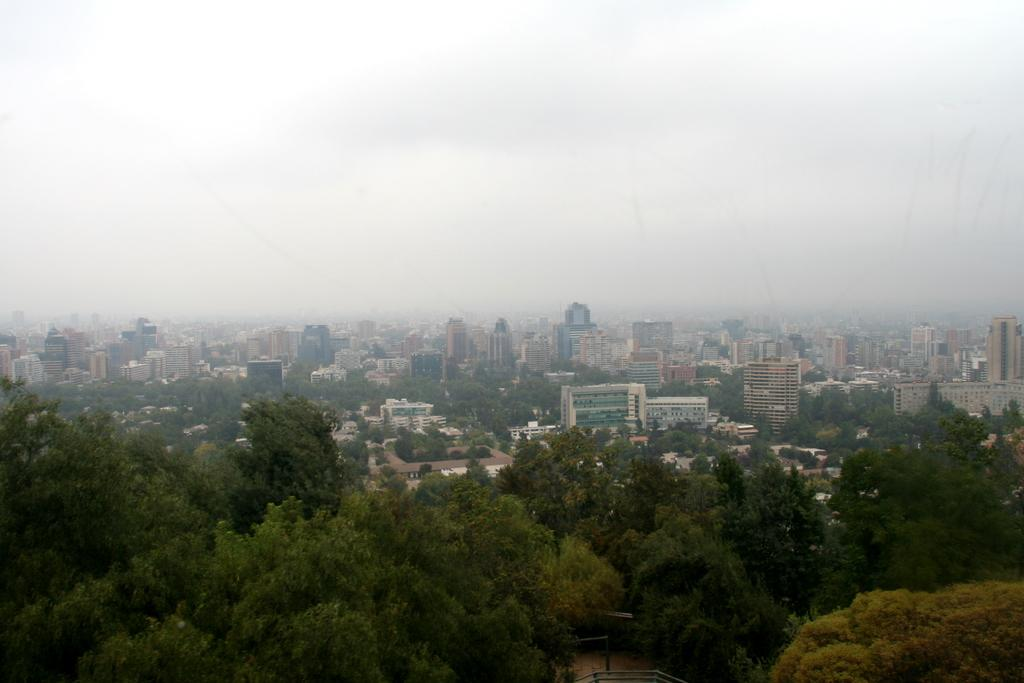What type of natural elements can be seen in the image? There are trees in the image. What type of man-made structures are present in the image? There are buildings in the image. What atmospheric condition is present in the image? There is fog in the image. What is visible at the top of the image? The sky is visible at the top of the image. What feature can be seen at the bottom of the image? There is a railing at the bottom of the image. How many pizzas are being served at the airport in the image? There is no airport or pizzas present in the image. What type of hen can be seen interacting with the trees in the image? There is no hen present in the image; only trees, buildings, fog, sky, and a railing are visible. 